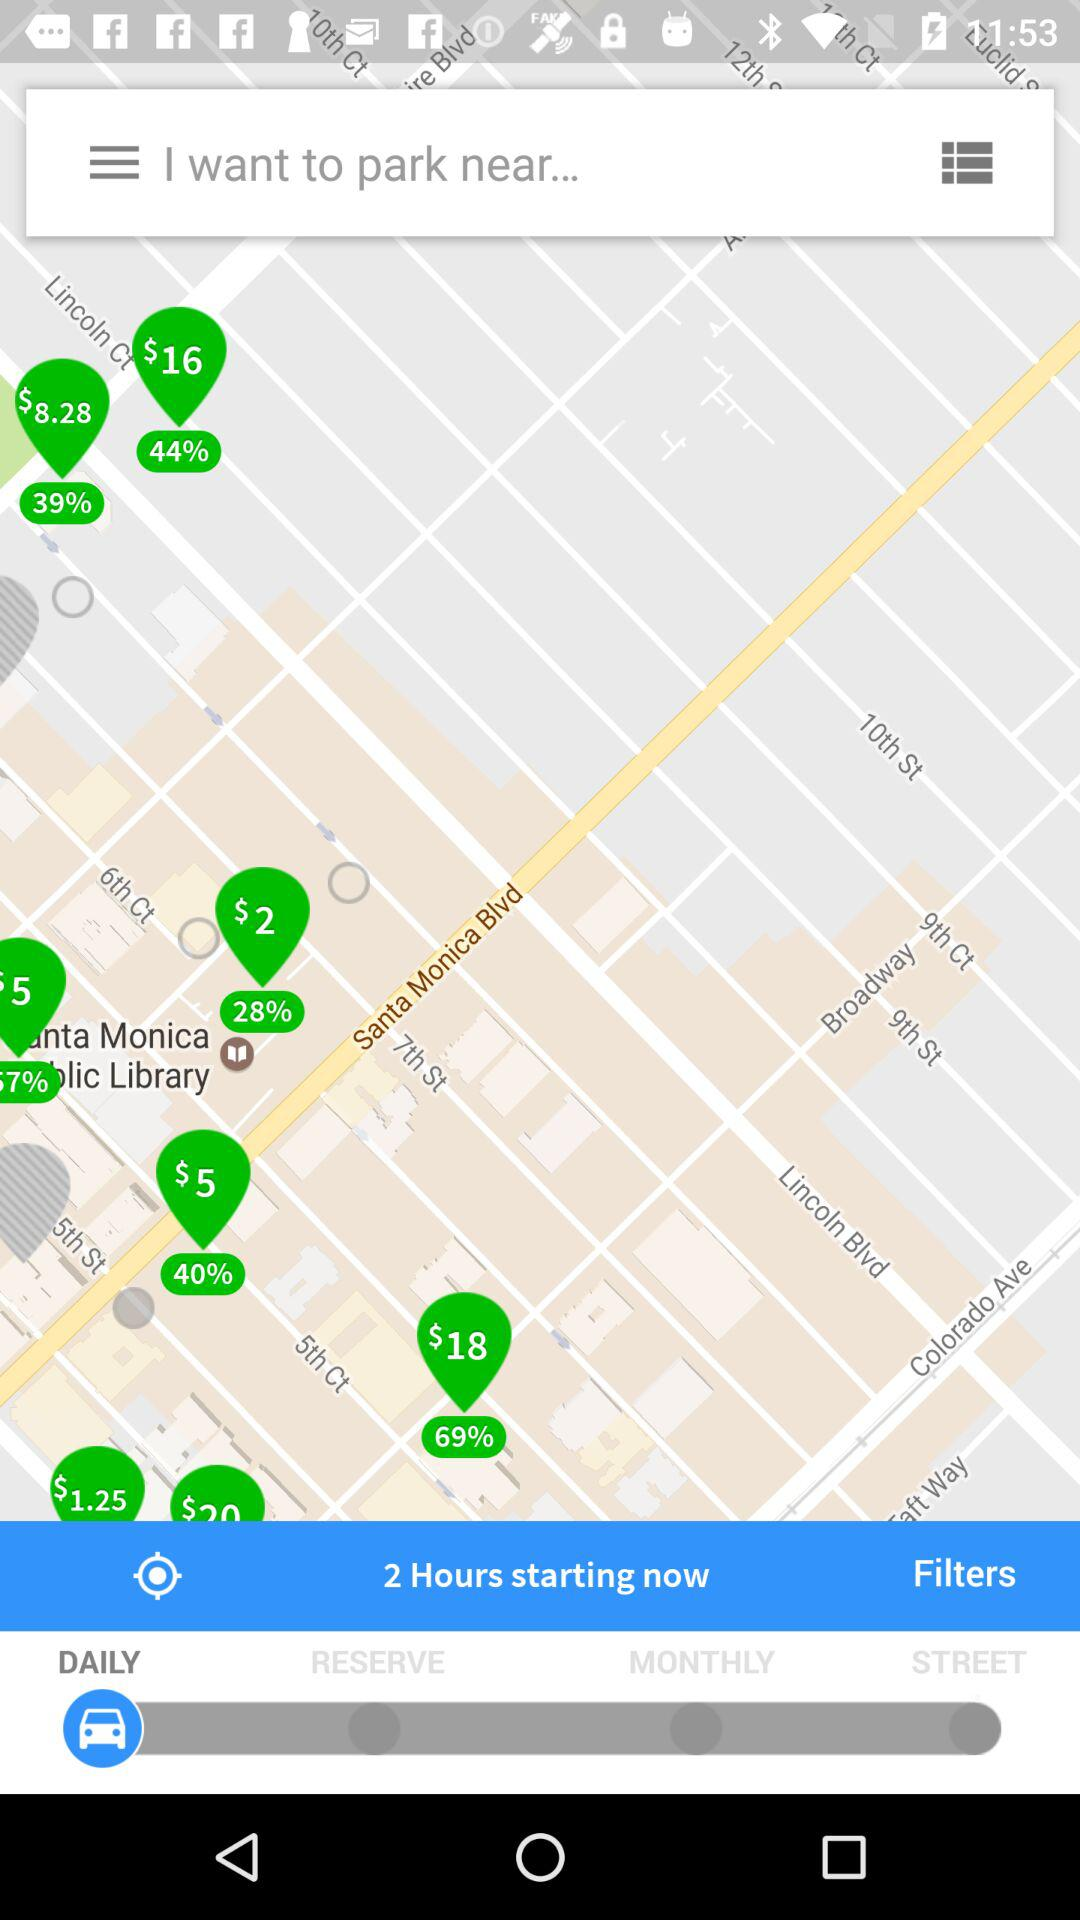What's the selected category? The selected category is "DAILY". 